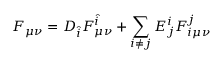Convert formula to latex. <formula><loc_0><loc_0><loc_500><loc_500>F _ { \mu \nu } = D _ { \hat { i } } F _ { \mu \nu } ^ { \hat { i } } + \sum _ { i \not = j } E _ { j } ^ { i } F _ { i \mu \nu } ^ { j }</formula> 